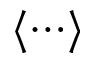Convert formula to latex. <formula><loc_0><loc_0><loc_500><loc_500>\langle \cdots \rangle</formula> 